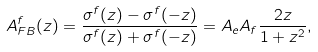<formula> <loc_0><loc_0><loc_500><loc_500>A _ { F B } ^ { f } ( z ) = \frac { \sigma ^ { f } ( z ) - \sigma ^ { f } ( - z ) } { \sigma ^ { f } ( z ) + \sigma ^ { f } ( - z ) } = A _ { e } A _ { f } \frac { 2 z } { 1 + z ^ { 2 } } ,</formula> 